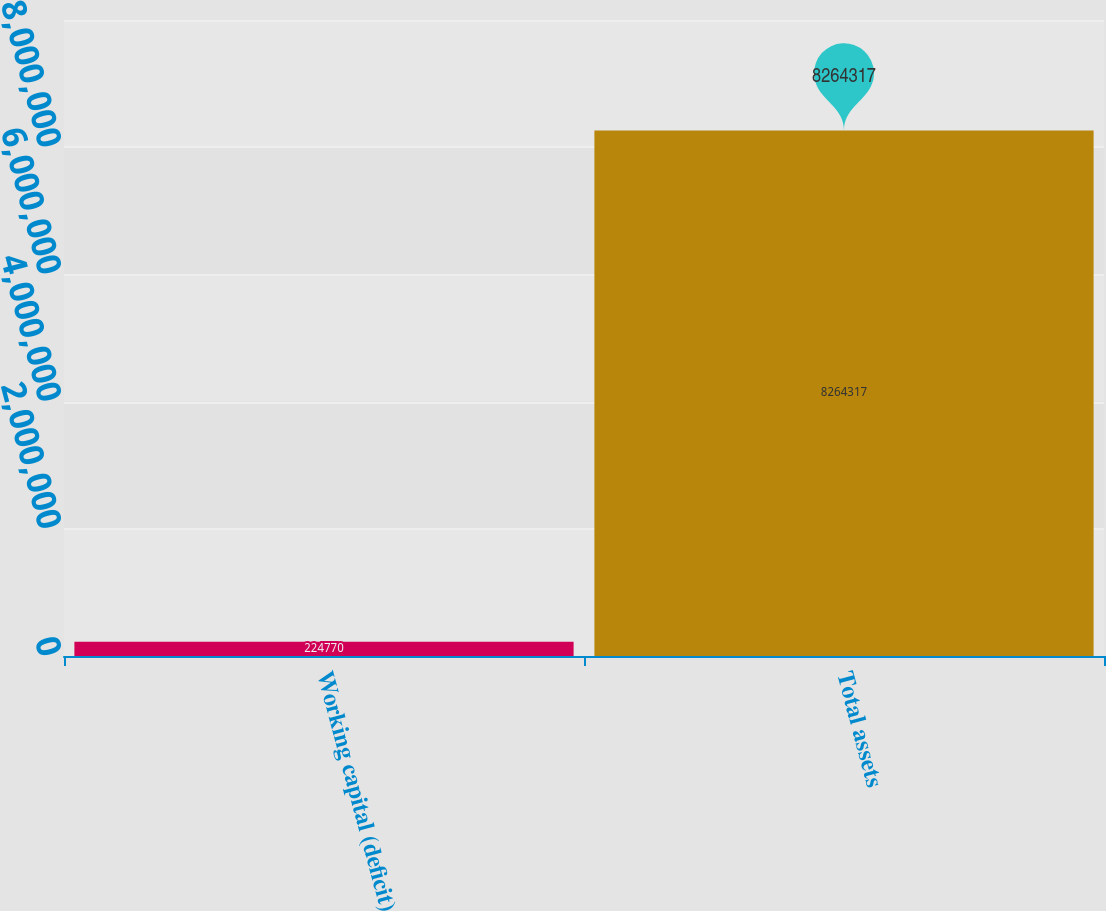Convert chart to OTSL. <chart><loc_0><loc_0><loc_500><loc_500><bar_chart><fcel>Working capital (deficit)<fcel>Total assets<nl><fcel>224770<fcel>8.26432e+06<nl></chart> 